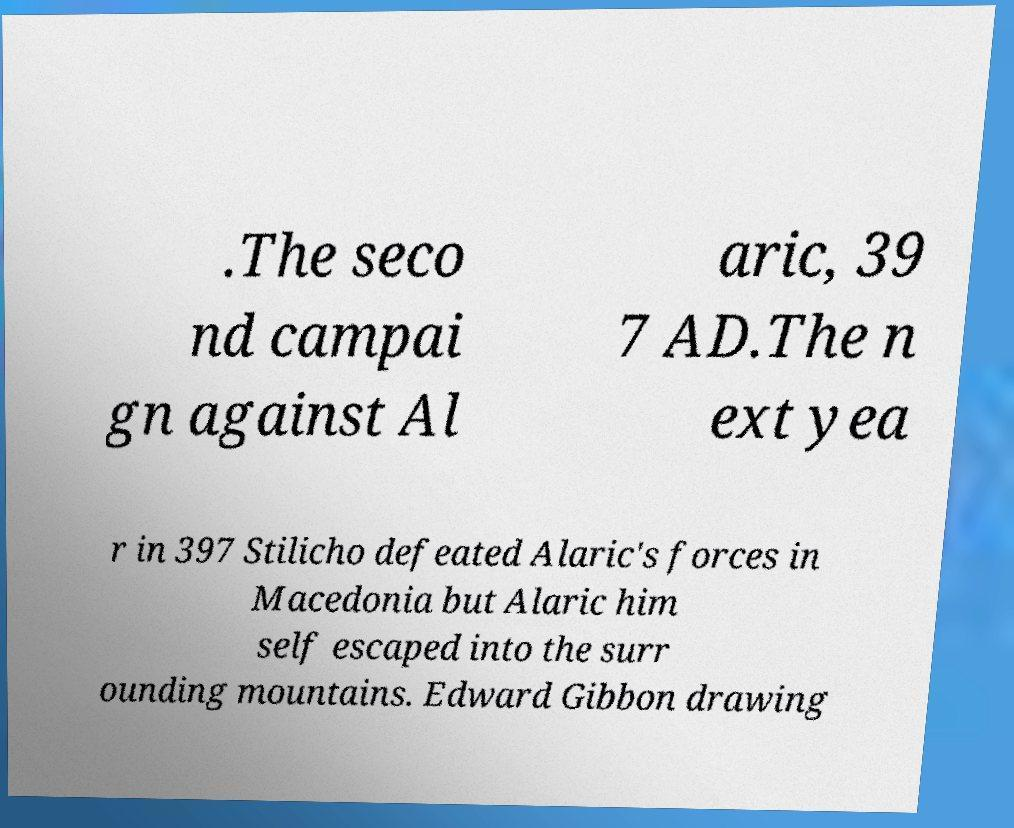Can you read and provide the text displayed in the image?This photo seems to have some interesting text. Can you extract and type it out for me? .The seco nd campai gn against Al aric, 39 7 AD.The n ext yea r in 397 Stilicho defeated Alaric's forces in Macedonia but Alaric him self escaped into the surr ounding mountains. Edward Gibbon drawing 